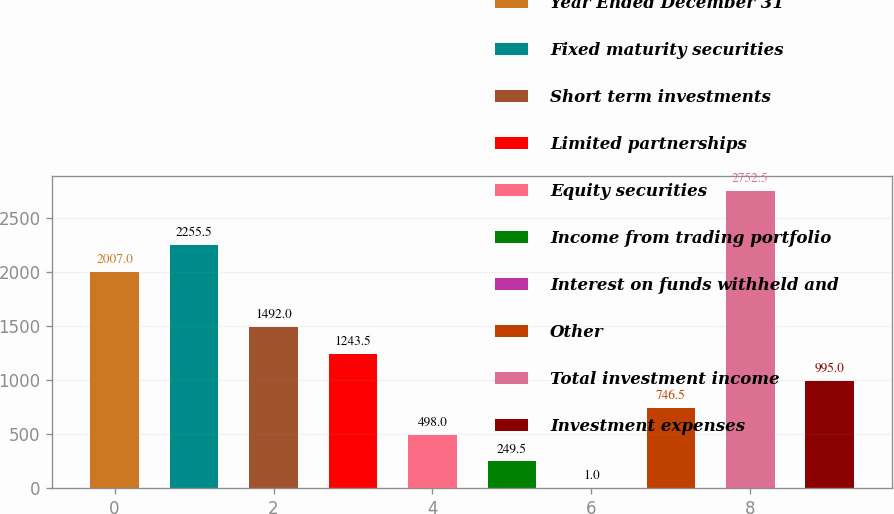Convert chart to OTSL. <chart><loc_0><loc_0><loc_500><loc_500><bar_chart><fcel>Year Ended December 31<fcel>Fixed maturity securities<fcel>Short term investments<fcel>Limited partnerships<fcel>Equity securities<fcel>Income from trading portfolio<fcel>Interest on funds withheld and<fcel>Other<fcel>Total investment income<fcel>Investment expenses<nl><fcel>2007<fcel>2255.5<fcel>1492<fcel>1243.5<fcel>498<fcel>249.5<fcel>1<fcel>746.5<fcel>2752.5<fcel>995<nl></chart> 